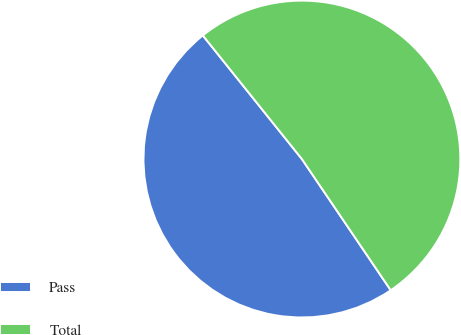Convert chart. <chart><loc_0><loc_0><loc_500><loc_500><pie_chart><fcel>Pass<fcel>Total<nl><fcel>48.72%<fcel>51.28%<nl></chart> 